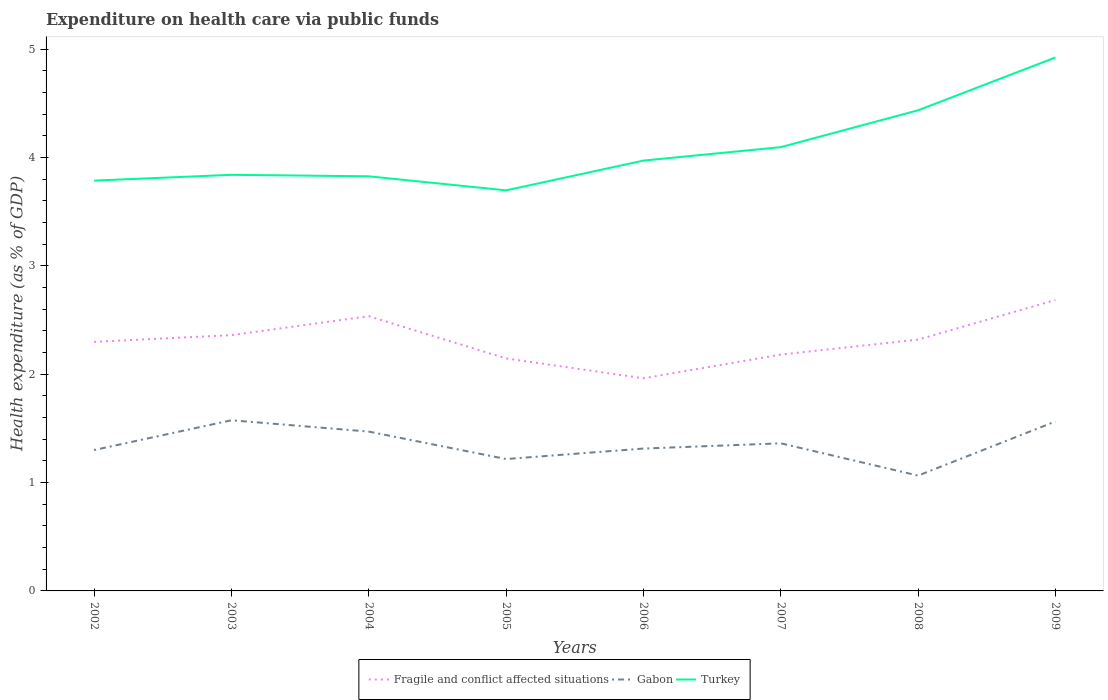How many different coloured lines are there?
Keep it short and to the point. 3. Does the line corresponding to Fragile and conflict affected situations intersect with the line corresponding to Turkey?
Ensure brevity in your answer.  No. Is the number of lines equal to the number of legend labels?
Ensure brevity in your answer.  Yes. Across all years, what is the maximum expenditure made on health care in Gabon?
Provide a succinct answer. 1.06. What is the total expenditure made on health care in Turkey in the graph?
Ensure brevity in your answer.  0.14. What is the difference between the highest and the second highest expenditure made on health care in Turkey?
Offer a terse response. 1.23. What is the difference between the highest and the lowest expenditure made on health care in Gabon?
Make the answer very short. 4. Is the expenditure made on health care in Turkey strictly greater than the expenditure made on health care in Fragile and conflict affected situations over the years?
Offer a terse response. No. What is the difference between two consecutive major ticks on the Y-axis?
Your answer should be very brief. 1. Does the graph contain grids?
Offer a terse response. No. How many legend labels are there?
Provide a short and direct response. 3. How are the legend labels stacked?
Give a very brief answer. Horizontal. What is the title of the graph?
Give a very brief answer. Expenditure on health care via public funds. Does "Aruba" appear as one of the legend labels in the graph?
Provide a short and direct response. No. What is the label or title of the Y-axis?
Your response must be concise. Health expenditure (as % of GDP). What is the Health expenditure (as % of GDP) in Fragile and conflict affected situations in 2002?
Offer a terse response. 2.3. What is the Health expenditure (as % of GDP) in Gabon in 2002?
Offer a terse response. 1.3. What is the Health expenditure (as % of GDP) in Turkey in 2002?
Your response must be concise. 3.79. What is the Health expenditure (as % of GDP) of Fragile and conflict affected situations in 2003?
Offer a very short reply. 2.36. What is the Health expenditure (as % of GDP) in Gabon in 2003?
Your answer should be very brief. 1.57. What is the Health expenditure (as % of GDP) of Turkey in 2003?
Keep it short and to the point. 3.84. What is the Health expenditure (as % of GDP) in Fragile and conflict affected situations in 2004?
Provide a short and direct response. 2.54. What is the Health expenditure (as % of GDP) in Gabon in 2004?
Give a very brief answer. 1.47. What is the Health expenditure (as % of GDP) of Turkey in 2004?
Offer a terse response. 3.83. What is the Health expenditure (as % of GDP) of Fragile and conflict affected situations in 2005?
Your answer should be very brief. 2.15. What is the Health expenditure (as % of GDP) of Gabon in 2005?
Provide a succinct answer. 1.22. What is the Health expenditure (as % of GDP) of Turkey in 2005?
Your response must be concise. 3.7. What is the Health expenditure (as % of GDP) in Fragile and conflict affected situations in 2006?
Your answer should be very brief. 1.96. What is the Health expenditure (as % of GDP) of Gabon in 2006?
Offer a terse response. 1.31. What is the Health expenditure (as % of GDP) of Turkey in 2006?
Provide a succinct answer. 3.97. What is the Health expenditure (as % of GDP) of Fragile and conflict affected situations in 2007?
Ensure brevity in your answer.  2.18. What is the Health expenditure (as % of GDP) in Gabon in 2007?
Keep it short and to the point. 1.36. What is the Health expenditure (as % of GDP) of Turkey in 2007?
Make the answer very short. 4.1. What is the Health expenditure (as % of GDP) of Fragile and conflict affected situations in 2008?
Your answer should be very brief. 2.32. What is the Health expenditure (as % of GDP) in Gabon in 2008?
Ensure brevity in your answer.  1.06. What is the Health expenditure (as % of GDP) of Turkey in 2008?
Offer a terse response. 4.44. What is the Health expenditure (as % of GDP) of Fragile and conflict affected situations in 2009?
Your answer should be compact. 2.68. What is the Health expenditure (as % of GDP) of Gabon in 2009?
Give a very brief answer. 1.56. What is the Health expenditure (as % of GDP) in Turkey in 2009?
Ensure brevity in your answer.  4.92. Across all years, what is the maximum Health expenditure (as % of GDP) in Fragile and conflict affected situations?
Offer a terse response. 2.68. Across all years, what is the maximum Health expenditure (as % of GDP) of Gabon?
Keep it short and to the point. 1.57. Across all years, what is the maximum Health expenditure (as % of GDP) in Turkey?
Your response must be concise. 4.92. Across all years, what is the minimum Health expenditure (as % of GDP) in Fragile and conflict affected situations?
Make the answer very short. 1.96. Across all years, what is the minimum Health expenditure (as % of GDP) of Gabon?
Make the answer very short. 1.06. Across all years, what is the minimum Health expenditure (as % of GDP) of Turkey?
Your response must be concise. 3.7. What is the total Health expenditure (as % of GDP) of Fragile and conflict affected situations in the graph?
Your response must be concise. 18.49. What is the total Health expenditure (as % of GDP) of Gabon in the graph?
Your answer should be very brief. 10.87. What is the total Health expenditure (as % of GDP) in Turkey in the graph?
Keep it short and to the point. 32.57. What is the difference between the Health expenditure (as % of GDP) of Fragile and conflict affected situations in 2002 and that in 2003?
Your response must be concise. -0.06. What is the difference between the Health expenditure (as % of GDP) in Gabon in 2002 and that in 2003?
Offer a terse response. -0.27. What is the difference between the Health expenditure (as % of GDP) of Turkey in 2002 and that in 2003?
Ensure brevity in your answer.  -0.05. What is the difference between the Health expenditure (as % of GDP) of Fragile and conflict affected situations in 2002 and that in 2004?
Your answer should be compact. -0.24. What is the difference between the Health expenditure (as % of GDP) of Gabon in 2002 and that in 2004?
Your answer should be compact. -0.17. What is the difference between the Health expenditure (as % of GDP) of Turkey in 2002 and that in 2004?
Keep it short and to the point. -0.04. What is the difference between the Health expenditure (as % of GDP) of Fragile and conflict affected situations in 2002 and that in 2005?
Offer a very short reply. 0.15. What is the difference between the Health expenditure (as % of GDP) of Gabon in 2002 and that in 2005?
Keep it short and to the point. 0.08. What is the difference between the Health expenditure (as % of GDP) in Turkey in 2002 and that in 2005?
Keep it short and to the point. 0.09. What is the difference between the Health expenditure (as % of GDP) in Fragile and conflict affected situations in 2002 and that in 2006?
Give a very brief answer. 0.34. What is the difference between the Health expenditure (as % of GDP) of Gabon in 2002 and that in 2006?
Provide a succinct answer. -0.01. What is the difference between the Health expenditure (as % of GDP) in Turkey in 2002 and that in 2006?
Keep it short and to the point. -0.18. What is the difference between the Health expenditure (as % of GDP) of Fragile and conflict affected situations in 2002 and that in 2007?
Offer a very short reply. 0.12. What is the difference between the Health expenditure (as % of GDP) in Gabon in 2002 and that in 2007?
Provide a succinct answer. -0.06. What is the difference between the Health expenditure (as % of GDP) of Turkey in 2002 and that in 2007?
Your answer should be very brief. -0.31. What is the difference between the Health expenditure (as % of GDP) in Fragile and conflict affected situations in 2002 and that in 2008?
Your response must be concise. -0.02. What is the difference between the Health expenditure (as % of GDP) of Gabon in 2002 and that in 2008?
Give a very brief answer. 0.24. What is the difference between the Health expenditure (as % of GDP) of Turkey in 2002 and that in 2008?
Ensure brevity in your answer.  -0.65. What is the difference between the Health expenditure (as % of GDP) in Fragile and conflict affected situations in 2002 and that in 2009?
Your answer should be very brief. -0.39. What is the difference between the Health expenditure (as % of GDP) in Gabon in 2002 and that in 2009?
Your answer should be compact. -0.26. What is the difference between the Health expenditure (as % of GDP) of Turkey in 2002 and that in 2009?
Keep it short and to the point. -1.14. What is the difference between the Health expenditure (as % of GDP) of Fragile and conflict affected situations in 2003 and that in 2004?
Your answer should be compact. -0.17. What is the difference between the Health expenditure (as % of GDP) in Gabon in 2003 and that in 2004?
Ensure brevity in your answer.  0.1. What is the difference between the Health expenditure (as % of GDP) in Turkey in 2003 and that in 2004?
Offer a terse response. 0.01. What is the difference between the Health expenditure (as % of GDP) in Fragile and conflict affected situations in 2003 and that in 2005?
Keep it short and to the point. 0.21. What is the difference between the Health expenditure (as % of GDP) in Gabon in 2003 and that in 2005?
Provide a short and direct response. 0.36. What is the difference between the Health expenditure (as % of GDP) in Turkey in 2003 and that in 2005?
Provide a short and direct response. 0.14. What is the difference between the Health expenditure (as % of GDP) of Fragile and conflict affected situations in 2003 and that in 2006?
Offer a very short reply. 0.4. What is the difference between the Health expenditure (as % of GDP) of Gabon in 2003 and that in 2006?
Your response must be concise. 0.26. What is the difference between the Health expenditure (as % of GDP) in Turkey in 2003 and that in 2006?
Give a very brief answer. -0.13. What is the difference between the Health expenditure (as % of GDP) in Fragile and conflict affected situations in 2003 and that in 2007?
Offer a terse response. 0.18. What is the difference between the Health expenditure (as % of GDP) of Gabon in 2003 and that in 2007?
Your answer should be very brief. 0.21. What is the difference between the Health expenditure (as % of GDP) in Turkey in 2003 and that in 2007?
Your answer should be very brief. -0.26. What is the difference between the Health expenditure (as % of GDP) in Fragile and conflict affected situations in 2003 and that in 2008?
Ensure brevity in your answer.  0.04. What is the difference between the Health expenditure (as % of GDP) of Gabon in 2003 and that in 2008?
Your answer should be very brief. 0.51. What is the difference between the Health expenditure (as % of GDP) in Turkey in 2003 and that in 2008?
Provide a succinct answer. -0.6. What is the difference between the Health expenditure (as % of GDP) in Fragile and conflict affected situations in 2003 and that in 2009?
Keep it short and to the point. -0.32. What is the difference between the Health expenditure (as % of GDP) in Gabon in 2003 and that in 2009?
Ensure brevity in your answer.  0.01. What is the difference between the Health expenditure (as % of GDP) of Turkey in 2003 and that in 2009?
Your answer should be very brief. -1.08. What is the difference between the Health expenditure (as % of GDP) of Fragile and conflict affected situations in 2004 and that in 2005?
Your answer should be compact. 0.39. What is the difference between the Health expenditure (as % of GDP) in Gabon in 2004 and that in 2005?
Give a very brief answer. 0.25. What is the difference between the Health expenditure (as % of GDP) in Turkey in 2004 and that in 2005?
Ensure brevity in your answer.  0.13. What is the difference between the Health expenditure (as % of GDP) in Fragile and conflict affected situations in 2004 and that in 2006?
Give a very brief answer. 0.57. What is the difference between the Health expenditure (as % of GDP) of Gabon in 2004 and that in 2006?
Your answer should be very brief. 0.16. What is the difference between the Health expenditure (as % of GDP) in Turkey in 2004 and that in 2006?
Give a very brief answer. -0.14. What is the difference between the Health expenditure (as % of GDP) in Fragile and conflict affected situations in 2004 and that in 2007?
Your answer should be compact. 0.35. What is the difference between the Health expenditure (as % of GDP) in Gabon in 2004 and that in 2007?
Ensure brevity in your answer.  0.11. What is the difference between the Health expenditure (as % of GDP) in Turkey in 2004 and that in 2007?
Offer a terse response. -0.27. What is the difference between the Health expenditure (as % of GDP) in Fragile and conflict affected situations in 2004 and that in 2008?
Make the answer very short. 0.22. What is the difference between the Health expenditure (as % of GDP) of Gabon in 2004 and that in 2008?
Give a very brief answer. 0.41. What is the difference between the Health expenditure (as % of GDP) in Turkey in 2004 and that in 2008?
Provide a short and direct response. -0.61. What is the difference between the Health expenditure (as % of GDP) of Fragile and conflict affected situations in 2004 and that in 2009?
Your answer should be very brief. -0.15. What is the difference between the Health expenditure (as % of GDP) of Gabon in 2004 and that in 2009?
Your answer should be very brief. -0.09. What is the difference between the Health expenditure (as % of GDP) of Turkey in 2004 and that in 2009?
Offer a terse response. -1.1. What is the difference between the Health expenditure (as % of GDP) of Fragile and conflict affected situations in 2005 and that in 2006?
Your answer should be very brief. 0.18. What is the difference between the Health expenditure (as % of GDP) in Gabon in 2005 and that in 2006?
Give a very brief answer. -0.1. What is the difference between the Health expenditure (as % of GDP) in Turkey in 2005 and that in 2006?
Offer a terse response. -0.27. What is the difference between the Health expenditure (as % of GDP) of Fragile and conflict affected situations in 2005 and that in 2007?
Provide a short and direct response. -0.04. What is the difference between the Health expenditure (as % of GDP) of Gabon in 2005 and that in 2007?
Give a very brief answer. -0.14. What is the difference between the Health expenditure (as % of GDP) in Turkey in 2005 and that in 2007?
Keep it short and to the point. -0.4. What is the difference between the Health expenditure (as % of GDP) of Fragile and conflict affected situations in 2005 and that in 2008?
Offer a terse response. -0.17. What is the difference between the Health expenditure (as % of GDP) of Gabon in 2005 and that in 2008?
Make the answer very short. 0.15. What is the difference between the Health expenditure (as % of GDP) of Turkey in 2005 and that in 2008?
Your answer should be very brief. -0.74. What is the difference between the Health expenditure (as % of GDP) of Fragile and conflict affected situations in 2005 and that in 2009?
Make the answer very short. -0.54. What is the difference between the Health expenditure (as % of GDP) in Gabon in 2005 and that in 2009?
Offer a very short reply. -0.35. What is the difference between the Health expenditure (as % of GDP) of Turkey in 2005 and that in 2009?
Provide a short and direct response. -1.23. What is the difference between the Health expenditure (as % of GDP) of Fragile and conflict affected situations in 2006 and that in 2007?
Give a very brief answer. -0.22. What is the difference between the Health expenditure (as % of GDP) in Gabon in 2006 and that in 2007?
Ensure brevity in your answer.  -0.05. What is the difference between the Health expenditure (as % of GDP) of Turkey in 2006 and that in 2007?
Make the answer very short. -0.12. What is the difference between the Health expenditure (as % of GDP) in Fragile and conflict affected situations in 2006 and that in 2008?
Ensure brevity in your answer.  -0.36. What is the difference between the Health expenditure (as % of GDP) in Gabon in 2006 and that in 2008?
Offer a very short reply. 0.25. What is the difference between the Health expenditure (as % of GDP) of Turkey in 2006 and that in 2008?
Offer a terse response. -0.46. What is the difference between the Health expenditure (as % of GDP) in Fragile and conflict affected situations in 2006 and that in 2009?
Your answer should be compact. -0.72. What is the difference between the Health expenditure (as % of GDP) of Gabon in 2006 and that in 2009?
Ensure brevity in your answer.  -0.25. What is the difference between the Health expenditure (as % of GDP) in Turkey in 2006 and that in 2009?
Ensure brevity in your answer.  -0.95. What is the difference between the Health expenditure (as % of GDP) of Fragile and conflict affected situations in 2007 and that in 2008?
Your answer should be compact. -0.14. What is the difference between the Health expenditure (as % of GDP) of Gabon in 2007 and that in 2008?
Your answer should be compact. 0.3. What is the difference between the Health expenditure (as % of GDP) in Turkey in 2007 and that in 2008?
Offer a terse response. -0.34. What is the difference between the Health expenditure (as % of GDP) in Fragile and conflict affected situations in 2007 and that in 2009?
Ensure brevity in your answer.  -0.5. What is the difference between the Health expenditure (as % of GDP) of Gabon in 2007 and that in 2009?
Offer a very short reply. -0.2. What is the difference between the Health expenditure (as % of GDP) in Turkey in 2007 and that in 2009?
Ensure brevity in your answer.  -0.83. What is the difference between the Health expenditure (as % of GDP) in Fragile and conflict affected situations in 2008 and that in 2009?
Your answer should be very brief. -0.37. What is the difference between the Health expenditure (as % of GDP) in Gabon in 2008 and that in 2009?
Provide a short and direct response. -0.5. What is the difference between the Health expenditure (as % of GDP) in Turkey in 2008 and that in 2009?
Provide a short and direct response. -0.49. What is the difference between the Health expenditure (as % of GDP) in Fragile and conflict affected situations in 2002 and the Health expenditure (as % of GDP) in Gabon in 2003?
Provide a short and direct response. 0.72. What is the difference between the Health expenditure (as % of GDP) in Fragile and conflict affected situations in 2002 and the Health expenditure (as % of GDP) in Turkey in 2003?
Ensure brevity in your answer.  -1.54. What is the difference between the Health expenditure (as % of GDP) of Gabon in 2002 and the Health expenditure (as % of GDP) of Turkey in 2003?
Keep it short and to the point. -2.54. What is the difference between the Health expenditure (as % of GDP) in Fragile and conflict affected situations in 2002 and the Health expenditure (as % of GDP) in Gabon in 2004?
Provide a short and direct response. 0.83. What is the difference between the Health expenditure (as % of GDP) of Fragile and conflict affected situations in 2002 and the Health expenditure (as % of GDP) of Turkey in 2004?
Keep it short and to the point. -1.53. What is the difference between the Health expenditure (as % of GDP) of Gabon in 2002 and the Health expenditure (as % of GDP) of Turkey in 2004?
Ensure brevity in your answer.  -2.53. What is the difference between the Health expenditure (as % of GDP) in Fragile and conflict affected situations in 2002 and the Health expenditure (as % of GDP) in Gabon in 2005?
Your answer should be very brief. 1.08. What is the difference between the Health expenditure (as % of GDP) in Fragile and conflict affected situations in 2002 and the Health expenditure (as % of GDP) in Turkey in 2005?
Your answer should be compact. -1.4. What is the difference between the Health expenditure (as % of GDP) of Gabon in 2002 and the Health expenditure (as % of GDP) of Turkey in 2005?
Provide a succinct answer. -2.4. What is the difference between the Health expenditure (as % of GDP) in Fragile and conflict affected situations in 2002 and the Health expenditure (as % of GDP) in Gabon in 2006?
Give a very brief answer. 0.98. What is the difference between the Health expenditure (as % of GDP) in Fragile and conflict affected situations in 2002 and the Health expenditure (as % of GDP) in Turkey in 2006?
Your response must be concise. -1.67. What is the difference between the Health expenditure (as % of GDP) in Gabon in 2002 and the Health expenditure (as % of GDP) in Turkey in 2006?
Offer a terse response. -2.67. What is the difference between the Health expenditure (as % of GDP) in Fragile and conflict affected situations in 2002 and the Health expenditure (as % of GDP) in Gabon in 2007?
Offer a very short reply. 0.94. What is the difference between the Health expenditure (as % of GDP) in Fragile and conflict affected situations in 2002 and the Health expenditure (as % of GDP) in Turkey in 2007?
Your answer should be compact. -1.8. What is the difference between the Health expenditure (as % of GDP) in Gabon in 2002 and the Health expenditure (as % of GDP) in Turkey in 2007?
Your response must be concise. -2.8. What is the difference between the Health expenditure (as % of GDP) of Fragile and conflict affected situations in 2002 and the Health expenditure (as % of GDP) of Gabon in 2008?
Your response must be concise. 1.23. What is the difference between the Health expenditure (as % of GDP) of Fragile and conflict affected situations in 2002 and the Health expenditure (as % of GDP) of Turkey in 2008?
Offer a terse response. -2.14. What is the difference between the Health expenditure (as % of GDP) in Gabon in 2002 and the Health expenditure (as % of GDP) in Turkey in 2008?
Your answer should be compact. -3.14. What is the difference between the Health expenditure (as % of GDP) of Fragile and conflict affected situations in 2002 and the Health expenditure (as % of GDP) of Gabon in 2009?
Offer a very short reply. 0.73. What is the difference between the Health expenditure (as % of GDP) in Fragile and conflict affected situations in 2002 and the Health expenditure (as % of GDP) in Turkey in 2009?
Offer a very short reply. -2.62. What is the difference between the Health expenditure (as % of GDP) in Gabon in 2002 and the Health expenditure (as % of GDP) in Turkey in 2009?
Provide a short and direct response. -3.62. What is the difference between the Health expenditure (as % of GDP) of Fragile and conflict affected situations in 2003 and the Health expenditure (as % of GDP) of Gabon in 2004?
Keep it short and to the point. 0.89. What is the difference between the Health expenditure (as % of GDP) in Fragile and conflict affected situations in 2003 and the Health expenditure (as % of GDP) in Turkey in 2004?
Provide a short and direct response. -1.47. What is the difference between the Health expenditure (as % of GDP) of Gabon in 2003 and the Health expenditure (as % of GDP) of Turkey in 2004?
Provide a short and direct response. -2.25. What is the difference between the Health expenditure (as % of GDP) in Fragile and conflict affected situations in 2003 and the Health expenditure (as % of GDP) in Gabon in 2005?
Offer a very short reply. 1.14. What is the difference between the Health expenditure (as % of GDP) in Fragile and conflict affected situations in 2003 and the Health expenditure (as % of GDP) in Turkey in 2005?
Give a very brief answer. -1.34. What is the difference between the Health expenditure (as % of GDP) in Gabon in 2003 and the Health expenditure (as % of GDP) in Turkey in 2005?
Your response must be concise. -2.12. What is the difference between the Health expenditure (as % of GDP) of Fragile and conflict affected situations in 2003 and the Health expenditure (as % of GDP) of Gabon in 2006?
Your answer should be very brief. 1.05. What is the difference between the Health expenditure (as % of GDP) of Fragile and conflict affected situations in 2003 and the Health expenditure (as % of GDP) of Turkey in 2006?
Your response must be concise. -1.61. What is the difference between the Health expenditure (as % of GDP) of Gabon in 2003 and the Health expenditure (as % of GDP) of Turkey in 2006?
Your answer should be very brief. -2.4. What is the difference between the Health expenditure (as % of GDP) in Fragile and conflict affected situations in 2003 and the Health expenditure (as % of GDP) in Turkey in 2007?
Provide a short and direct response. -1.73. What is the difference between the Health expenditure (as % of GDP) in Gabon in 2003 and the Health expenditure (as % of GDP) in Turkey in 2007?
Offer a very short reply. -2.52. What is the difference between the Health expenditure (as % of GDP) in Fragile and conflict affected situations in 2003 and the Health expenditure (as % of GDP) in Gabon in 2008?
Your answer should be compact. 1.3. What is the difference between the Health expenditure (as % of GDP) of Fragile and conflict affected situations in 2003 and the Health expenditure (as % of GDP) of Turkey in 2008?
Your response must be concise. -2.07. What is the difference between the Health expenditure (as % of GDP) in Gabon in 2003 and the Health expenditure (as % of GDP) in Turkey in 2008?
Give a very brief answer. -2.86. What is the difference between the Health expenditure (as % of GDP) of Fragile and conflict affected situations in 2003 and the Health expenditure (as % of GDP) of Gabon in 2009?
Your answer should be very brief. 0.8. What is the difference between the Health expenditure (as % of GDP) of Fragile and conflict affected situations in 2003 and the Health expenditure (as % of GDP) of Turkey in 2009?
Provide a short and direct response. -2.56. What is the difference between the Health expenditure (as % of GDP) in Gabon in 2003 and the Health expenditure (as % of GDP) in Turkey in 2009?
Make the answer very short. -3.35. What is the difference between the Health expenditure (as % of GDP) in Fragile and conflict affected situations in 2004 and the Health expenditure (as % of GDP) in Gabon in 2005?
Ensure brevity in your answer.  1.32. What is the difference between the Health expenditure (as % of GDP) in Fragile and conflict affected situations in 2004 and the Health expenditure (as % of GDP) in Turkey in 2005?
Ensure brevity in your answer.  -1.16. What is the difference between the Health expenditure (as % of GDP) of Gabon in 2004 and the Health expenditure (as % of GDP) of Turkey in 2005?
Your answer should be compact. -2.23. What is the difference between the Health expenditure (as % of GDP) in Fragile and conflict affected situations in 2004 and the Health expenditure (as % of GDP) in Gabon in 2006?
Offer a terse response. 1.22. What is the difference between the Health expenditure (as % of GDP) in Fragile and conflict affected situations in 2004 and the Health expenditure (as % of GDP) in Turkey in 2006?
Ensure brevity in your answer.  -1.44. What is the difference between the Health expenditure (as % of GDP) in Gabon in 2004 and the Health expenditure (as % of GDP) in Turkey in 2006?
Your answer should be compact. -2.5. What is the difference between the Health expenditure (as % of GDP) in Fragile and conflict affected situations in 2004 and the Health expenditure (as % of GDP) in Gabon in 2007?
Offer a very short reply. 1.17. What is the difference between the Health expenditure (as % of GDP) of Fragile and conflict affected situations in 2004 and the Health expenditure (as % of GDP) of Turkey in 2007?
Your answer should be very brief. -1.56. What is the difference between the Health expenditure (as % of GDP) in Gabon in 2004 and the Health expenditure (as % of GDP) in Turkey in 2007?
Provide a succinct answer. -2.62. What is the difference between the Health expenditure (as % of GDP) of Fragile and conflict affected situations in 2004 and the Health expenditure (as % of GDP) of Gabon in 2008?
Give a very brief answer. 1.47. What is the difference between the Health expenditure (as % of GDP) of Gabon in 2004 and the Health expenditure (as % of GDP) of Turkey in 2008?
Provide a succinct answer. -2.97. What is the difference between the Health expenditure (as % of GDP) in Fragile and conflict affected situations in 2004 and the Health expenditure (as % of GDP) in Gabon in 2009?
Offer a very short reply. 0.97. What is the difference between the Health expenditure (as % of GDP) of Fragile and conflict affected situations in 2004 and the Health expenditure (as % of GDP) of Turkey in 2009?
Your response must be concise. -2.39. What is the difference between the Health expenditure (as % of GDP) in Gabon in 2004 and the Health expenditure (as % of GDP) in Turkey in 2009?
Keep it short and to the point. -3.45. What is the difference between the Health expenditure (as % of GDP) of Fragile and conflict affected situations in 2005 and the Health expenditure (as % of GDP) of Gabon in 2006?
Your response must be concise. 0.83. What is the difference between the Health expenditure (as % of GDP) in Fragile and conflict affected situations in 2005 and the Health expenditure (as % of GDP) in Turkey in 2006?
Give a very brief answer. -1.83. What is the difference between the Health expenditure (as % of GDP) in Gabon in 2005 and the Health expenditure (as % of GDP) in Turkey in 2006?
Ensure brevity in your answer.  -2.75. What is the difference between the Health expenditure (as % of GDP) of Fragile and conflict affected situations in 2005 and the Health expenditure (as % of GDP) of Gabon in 2007?
Provide a short and direct response. 0.78. What is the difference between the Health expenditure (as % of GDP) in Fragile and conflict affected situations in 2005 and the Health expenditure (as % of GDP) in Turkey in 2007?
Provide a succinct answer. -1.95. What is the difference between the Health expenditure (as % of GDP) of Gabon in 2005 and the Health expenditure (as % of GDP) of Turkey in 2007?
Offer a terse response. -2.88. What is the difference between the Health expenditure (as % of GDP) of Fragile and conflict affected situations in 2005 and the Health expenditure (as % of GDP) of Gabon in 2008?
Your answer should be very brief. 1.08. What is the difference between the Health expenditure (as % of GDP) of Fragile and conflict affected situations in 2005 and the Health expenditure (as % of GDP) of Turkey in 2008?
Provide a succinct answer. -2.29. What is the difference between the Health expenditure (as % of GDP) in Gabon in 2005 and the Health expenditure (as % of GDP) in Turkey in 2008?
Give a very brief answer. -3.22. What is the difference between the Health expenditure (as % of GDP) in Fragile and conflict affected situations in 2005 and the Health expenditure (as % of GDP) in Gabon in 2009?
Your answer should be very brief. 0.58. What is the difference between the Health expenditure (as % of GDP) in Fragile and conflict affected situations in 2005 and the Health expenditure (as % of GDP) in Turkey in 2009?
Provide a short and direct response. -2.78. What is the difference between the Health expenditure (as % of GDP) of Gabon in 2005 and the Health expenditure (as % of GDP) of Turkey in 2009?
Provide a succinct answer. -3.71. What is the difference between the Health expenditure (as % of GDP) of Fragile and conflict affected situations in 2006 and the Health expenditure (as % of GDP) of Gabon in 2007?
Make the answer very short. 0.6. What is the difference between the Health expenditure (as % of GDP) of Fragile and conflict affected situations in 2006 and the Health expenditure (as % of GDP) of Turkey in 2007?
Make the answer very short. -2.13. What is the difference between the Health expenditure (as % of GDP) of Gabon in 2006 and the Health expenditure (as % of GDP) of Turkey in 2007?
Keep it short and to the point. -2.78. What is the difference between the Health expenditure (as % of GDP) of Fragile and conflict affected situations in 2006 and the Health expenditure (as % of GDP) of Gabon in 2008?
Ensure brevity in your answer.  0.9. What is the difference between the Health expenditure (as % of GDP) of Fragile and conflict affected situations in 2006 and the Health expenditure (as % of GDP) of Turkey in 2008?
Offer a terse response. -2.47. What is the difference between the Health expenditure (as % of GDP) in Gabon in 2006 and the Health expenditure (as % of GDP) in Turkey in 2008?
Your answer should be compact. -3.12. What is the difference between the Health expenditure (as % of GDP) in Fragile and conflict affected situations in 2006 and the Health expenditure (as % of GDP) in Gabon in 2009?
Keep it short and to the point. 0.4. What is the difference between the Health expenditure (as % of GDP) of Fragile and conflict affected situations in 2006 and the Health expenditure (as % of GDP) of Turkey in 2009?
Give a very brief answer. -2.96. What is the difference between the Health expenditure (as % of GDP) in Gabon in 2006 and the Health expenditure (as % of GDP) in Turkey in 2009?
Keep it short and to the point. -3.61. What is the difference between the Health expenditure (as % of GDP) of Fragile and conflict affected situations in 2007 and the Health expenditure (as % of GDP) of Gabon in 2008?
Your answer should be compact. 1.12. What is the difference between the Health expenditure (as % of GDP) of Fragile and conflict affected situations in 2007 and the Health expenditure (as % of GDP) of Turkey in 2008?
Provide a succinct answer. -2.25. What is the difference between the Health expenditure (as % of GDP) in Gabon in 2007 and the Health expenditure (as % of GDP) in Turkey in 2008?
Give a very brief answer. -3.07. What is the difference between the Health expenditure (as % of GDP) in Fragile and conflict affected situations in 2007 and the Health expenditure (as % of GDP) in Gabon in 2009?
Ensure brevity in your answer.  0.62. What is the difference between the Health expenditure (as % of GDP) of Fragile and conflict affected situations in 2007 and the Health expenditure (as % of GDP) of Turkey in 2009?
Your response must be concise. -2.74. What is the difference between the Health expenditure (as % of GDP) in Gabon in 2007 and the Health expenditure (as % of GDP) in Turkey in 2009?
Your response must be concise. -3.56. What is the difference between the Health expenditure (as % of GDP) in Fragile and conflict affected situations in 2008 and the Health expenditure (as % of GDP) in Gabon in 2009?
Offer a terse response. 0.76. What is the difference between the Health expenditure (as % of GDP) in Fragile and conflict affected situations in 2008 and the Health expenditure (as % of GDP) in Turkey in 2009?
Your answer should be very brief. -2.6. What is the difference between the Health expenditure (as % of GDP) in Gabon in 2008 and the Health expenditure (as % of GDP) in Turkey in 2009?
Your response must be concise. -3.86. What is the average Health expenditure (as % of GDP) in Fragile and conflict affected situations per year?
Make the answer very short. 2.31. What is the average Health expenditure (as % of GDP) in Gabon per year?
Your answer should be very brief. 1.36. What is the average Health expenditure (as % of GDP) in Turkey per year?
Make the answer very short. 4.07. In the year 2002, what is the difference between the Health expenditure (as % of GDP) in Fragile and conflict affected situations and Health expenditure (as % of GDP) in Gabon?
Ensure brevity in your answer.  1. In the year 2002, what is the difference between the Health expenditure (as % of GDP) of Fragile and conflict affected situations and Health expenditure (as % of GDP) of Turkey?
Make the answer very short. -1.49. In the year 2002, what is the difference between the Health expenditure (as % of GDP) of Gabon and Health expenditure (as % of GDP) of Turkey?
Make the answer very short. -2.49. In the year 2003, what is the difference between the Health expenditure (as % of GDP) in Fragile and conflict affected situations and Health expenditure (as % of GDP) in Gabon?
Ensure brevity in your answer.  0.79. In the year 2003, what is the difference between the Health expenditure (as % of GDP) of Fragile and conflict affected situations and Health expenditure (as % of GDP) of Turkey?
Ensure brevity in your answer.  -1.48. In the year 2003, what is the difference between the Health expenditure (as % of GDP) in Gabon and Health expenditure (as % of GDP) in Turkey?
Offer a very short reply. -2.26. In the year 2004, what is the difference between the Health expenditure (as % of GDP) of Fragile and conflict affected situations and Health expenditure (as % of GDP) of Gabon?
Your answer should be compact. 1.07. In the year 2004, what is the difference between the Health expenditure (as % of GDP) in Fragile and conflict affected situations and Health expenditure (as % of GDP) in Turkey?
Offer a very short reply. -1.29. In the year 2004, what is the difference between the Health expenditure (as % of GDP) in Gabon and Health expenditure (as % of GDP) in Turkey?
Give a very brief answer. -2.36. In the year 2005, what is the difference between the Health expenditure (as % of GDP) of Fragile and conflict affected situations and Health expenditure (as % of GDP) of Gabon?
Your answer should be compact. 0.93. In the year 2005, what is the difference between the Health expenditure (as % of GDP) in Fragile and conflict affected situations and Health expenditure (as % of GDP) in Turkey?
Your answer should be very brief. -1.55. In the year 2005, what is the difference between the Health expenditure (as % of GDP) in Gabon and Health expenditure (as % of GDP) in Turkey?
Offer a terse response. -2.48. In the year 2006, what is the difference between the Health expenditure (as % of GDP) in Fragile and conflict affected situations and Health expenditure (as % of GDP) in Gabon?
Your response must be concise. 0.65. In the year 2006, what is the difference between the Health expenditure (as % of GDP) of Fragile and conflict affected situations and Health expenditure (as % of GDP) of Turkey?
Provide a short and direct response. -2.01. In the year 2006, what is the difference between the Health expenditure (as % of GDP) in Gabon and Health expenditure (as % of GDP) in Turkey?
Your answer should be very brief. -2.66. In the year 2007, what is the difference between the Health expenditure (as % of GDP) of Fragile and conflict affected situations and Health expenditure (as % of GDP) of Gabon?
Ensure brevity in your answer.  0.82. In the year 2007, what is the difference between the Health expenditure (as % of GDP) in Fragile and conflict affected situations and Health expenditure (as % of GDP) in Turkey?
Your answer should be very brief. -1.91. In the year 2007, what is the difference between the Health expenditure (as % of GDP) in Gabon and Health expenditure (as % of GDP) in Turkey?
Keep it short and to the point. -2.73. In the year 2008, what is the difference between the Health expenditure (as % of GDP) in Fragile and conflict affected situations and Health expenditure (as % of GDP) in Gabon?
Your response must be concise. 1.26. In the year 2008, what is the difference between the Health expenditure (as % of GDP) in Fragile and conflict affected situations and Health expenditure (as % of GDP) in Turkey?
Make the answer very short. -2.12. In the year 2008, what is the difference between the Health expenditure (as % of GDP) in Gabon and Health expenditure (as % of GDP) in Turkey?
Ensure brevity in your answer.  -3.37. In the year 2009, what is the difference between the Health expenditure (as % of GDP) in Fragile and conflict affected situations and Health expenditure (as % of GDP) in Gabon?
Your answer should be very brief. 1.12. In the year 2009, what is the difference between the Health expenditure (as % of GDP) in Fragile and conflict affected situations and Health expenditure (as % of GDP) in Turkey?
Your answer should be very brief. -2.24. In the year 2009, what is the difference between the Health expenditure (as % of GDP) of Gabon and Health expenditure (as % of GDP) of Turkey?
Make the answer very short. -3.36. What is the ratio of the Health expenditure (as % of GDP) of Fragile and conflict affected situations in 2002 to that in 2003?
Keep it short and to the point. 0.97. What is the ratio of the Health expenditure (as % of GDP) of Gabon in 2002 to that in 2003?
Give a very brief answer. 0.83. What is the ratio of the Health expenditure (as % of GDP) of Turkey in 2002 to that in 2003?
Give a very brief answer. 0.99. What is the ratio of the Health expenditure (as % of GDP) of Fragile and conflict affected situations in 2002 to that in 2004?
Provide a short and direct response. 0.91. What is the ratio of the Health expenditure (as % of GDP) in Gabon in 2002 to that in 2004?
Ensure brevity in your answer.  0.88. What is the ratio of the Health expenditure (as % of GDP) of Fragile and conflict affected situations in 2002 to that in 2005?
Your response must be concise. 1.07. What is the ratio of the Health expenditure (as % of GDP) in Gabon in 2002 to that in 2005?
Your response must be concise. 1.07. What is the ratio of the Health expenditure (as % of GDP) in Turkey in 2002 to that in 2005?
Your answer should be very brief. 1.02. What is the ratio of the Health expenditure (as % of GDP) in Fragile and conflict affected situations in 2002 to that in 2006?
Make the answer very short. 1.17. What is the ratio of the Health expenditure (as % of GDP) of Turkey in 2002 to that in 2006?
Your answer should be compact. 0.95. What is the ratio of the Health expenditure (as % of GDP) of Fragile and conflict affected situations in 2002 to that in 2007?
Provide a short and direct response. 1.05. What is the ratio of the Health expenditure (as % of GDP) of Gabon in 2002 to that in 2007?
Your answer should be compact. 0.95. What is the ratio of the Health expenditure (as % of GDP) of Turkey in 2002 to that in 2007?
Keep it short and to the point. 0.92. What is the ratio of the Health expenditure (as % of GDP) of Fragile and conflict affected situations in 2002 to that in 2008?
Ensure brevity in your answer.  0.99. What is the ratio of the Health expenditure (as % of GDP) in Gabon in 2002 to that in 2008?
Keep it short and to the point. 1.22. What is the ratio of the Health expenditure (as % of GDP) in Turkey in 2002 to that in 2008?
Make the answer very short. 0.85. What is the ratio of the Health expenditure (as % of GDP) in Fragile and conflict affected situations in 2002 to that in 2009?
Provide a short and direct response. 0.86. What is the ratio of the Health expenditure (as % of GDP) of Gabon in 2002 to that in 2009?
Give a very brief answer. 0.83. What is the ratio of the Health expenditure (as % of GDP) in Turkey in 2002 to that in 2009?
Make the answer very short. 0.77. What is the ratio of the Health expenditure (as % of GDP) in Fragile and conflict affected situations in 2003 to that in 2004?
Provide a succinct answer. 0.93. What is the ratio of the Health expenditure (as % of GDP) in Gabon in 2003 to that in 2004?
Your response must be concise. 1.07. What is the ratio of the Health expenditure (as % of GDP) of Fragile and conflict affected situations in 2003 to that in 2005?
Your answer should be compact. 1.1. What is the ratio of the Health expenditure (as % of GDP) of Gabon in 2003 to that in 2005?
Provide a short and direct response. 1.29. What is the ratio of the Health expenditure (as % of GDP) in Turkey in 2003 to that in 2005?
Provide a succinct answer. 1.04. What is the ratio of the Health expenditure (as % of GDP) of Fragile and conflict affected situations in 2003 to that in 2006?
Your answer should be very brief. 1.2. What is the ratio of the Health expenditure (as % of GDP) of Gabon in 2003 to that in 2006?
Your response must be concise. 1.2. What is the ratio of the Health expenditure (as % of GDP) of Turkey in 2003 to that in 2006?
Your answer should be very brief. 0.97. What is the ratio of the Health expenditure (as % of GDP) of Fragile and conflict affected situations in 2003 to that in 2007?
Keep it short and to the point. 1.08. What is the ratio of the Health expenditure (as % of GDP) in Gabon in 2003 to that in 2007?
Your answer should be very brief. 1.16. What is the ratio of the Health expenditure (as % of GDP) of Turkey in 2003 to that in 2007?
Keep it short and to the point. 0.94. What is the ratio of the Health expenditure (as % of GDP) of Fragile and conflict affected situations in 2003 to that in 2008?
Offer a terse response. 1.02. What is the ratio of the Health expenditure (as % of GDP) in Gabon in 2003 to that in 2008?
Make the answer very short. 1.48. What is the ratio of the Health expenditure (as % of GDP) of Turkey in 2003 to that in 2008?
Give a very brief answer. 0.87. What is the ratio of the Health expenditure (as % of GDP) of Fragile and conflict affected situations in 2003 to that in 2009?
Give a very brief answer. 0.88. What is the ratio of the Health expenditure (as % of GDP) of Gabon in 2003 to that in 2009?
Offer a terse response. 1.01. What is the ratio of the Health expenditure (as % of GDP) in Turkey in 2003 to that in 2009?
Your answer should be compact. 0.78. What is the ratio of the Health expenditure (as % of GDP) in Fragile and conflict affected situations in 2004 to that in 2005?
Give a very brief answer. 1.18. What is the ratio of the Health expenditure (as % of GDP) of Gabon in 2004 to that in 2005?
Provide a succinct answer. 1.21. What is the ratio of the Health expenditure (as % of GDP) of Turkey in 2004 to that in 2005?
Your answer should be compact. 1.04. What is the ratio of the Health expenditure (as % of GDP) in Fragile and conflict affected situations in 2004 to that in 2006?
Keep it short and to the point. 1.29. What is the ratio of the Health expenditure (as % of GDP) of Gabon in 2004 to that in 2006?
Offer a very short reply. 1.12. What is the ratio of the Health expenditure (as % of GDP) in Turkey in 2004 to that in 2006?
Provide a succinct answer. 0.96. What is the ratio of the Health expenditure (as % of GDP) in Fragile and conflict affected situations in 2004 to that in 2007?
Ensure brevity in your answer.  1.16. What is the ratio of the Health expenditure (as % of GDP) of Gabon in 2004 to that in 2007?
Your answer should be compact. 1.08. What is the ratio of the Health expenditure (as % of GDP) in Turkey in 2004 to that in 2007?
Offer a very short reply. 0.93. What is the ratio of the Health expenditure (as % of GDP) of Fragile and conflict affected situations in 2004 to that in 2008?
Your answer should be compact. 1.09. What is the ratio of the Health expenditure (as % of GDP) in Gabon in 2004 to that in 2008?
Provide a succinct answer. 1.38. What is the ratio of the Health expenditure (as % of GDP) of Turkey in 2004 to that in 2008?
Ensure brevity in your answer.  0.86. What is the ratio of the Health expenditure (as % of GDP) in Fragile and conflict affected situations in 2004 to that in 2009?
Keep it short and to the point. 0.94. What is the ratio of the Health expenditure (as % of GDP) of Gabon in 2004 to that in 2009?
Keep it short and to the point. 0.94. What is the ratio of the Health expenditure (as % of GDP) in Turkey in 2004 to that in 2009?
Provide a short and direct response. 0.78. What is the ratio of the Health expenditure (as % of GDP) of Fragile and conflict affected situations in 2005 to that in 2006?
Ensure brevity in your answer.  1.09. What is the ratio of the Health expenditure (as % of GDP) in Gabon in 2005 to that in 2006?
Keep it short and to the point. 0.93. What is the ratio of the Health expenditure (as % of GDP) in Turkey in 2005 to that in 2006?
Your response must be concise. 0.93. What is the ratio of the Health expenditure (as % of GDP) of Fragile and conflict affected situations in 2005 to that in 2007?
Provide a succinct answer. 0.98. What is the ratio of the Health expenditure (as % of GDP) in Gabon in 2005 to that in 2007?
Ensure brevity in your answer.  0.89. What is the ratio of the Health expenditure (as % of GDP) of Turkey in 2005 to that in 2007?
Your answer should be very brief. 0.9. What is the ratio of the Health expenditure (as % of GDP) in Fragile and conflict affected situations in 2005 to that in 2008?
Give a very brief answer. 0.93. What is the ratio of the Health expenditure (as % of GDP) in Gabon in 2005 to that in 2008?
Keep it short and to the point. 1.14. What is the ratio of the Health expenditure (as % of GDP) of Turkey in 2005 to that in 2008?
Your answer should be compact. 0.83. What is the ratio of the Health expenditure (as % of GDP) in Fragile and conflict affected situations in 2005 to that in 2009?
Provide a short and direct response. 0.8. What is the ratio of the Health expenditure (as % of GDP) of Gabon in 2005 to that in 2009?
Offer a very short reply. 0.78. What is the ratio of the Health expenditure (as % of GDP) in Turkey in 2005 to that in 2009?
Your answer should be compact. 0.75. What is the ratio of the Health expenditure (as % of GDP) in Fragile and conflict affected situations in 2006 to that in 2007?
Keep it short and to the point. 0.9. What is the ratio of the Health expenditure (as % of GDP) of Gabon in 2006 to that in 2007?
Your answer should be very brief. 0.96. What is the ratio of the Health expenditure (as % of GDP) of Turkey in 2006 to that in 2007?
Make the answer very short. 0.97. What is the ratio of the Health expenditure (as % of GDP) in Fragile and conflict affected situations in 2006 to that in 2008?
Your answer should be compact. 0.85. What is the ratio of the Health expenditure (as % of GDP) of Gabon in 2006 to that in 2008?
Give a very brief answer. 1.23. What is the ratio of the Health expenditure (as % of GDP) in Turkey in 2006 to that in 2008?
Your response must be concise. 0.9. What is the ratio of the Health expenditure (as % of GDP) of Fragile and conflict affected situations in 2006 to that in 2009?
Provide a short and direct response. 0.73. What is the ratio of the Health expenditure (as % of GDP) in Gabon in 2006 to that in 2009?
Give a very brief answer. 0.84. What is the ratio of the Health expenditure (as % of GDP) in Turkey in 2006 to that in 2009?
Make the answer very short. 0.81. What is the ratio of the Health expenditure (as % of GDP) in Fragile and conflict affected situations in 2007 to that in 2008?
Make the answer very short. 0.94. What is the ratio of the Health expenditure (as % of GDP) of Gabon in 2007 to that in 2008?
Offer a very short reply. 1.28. What is the ratio of the Health expenditure (as % of GDP) in Turkey in 2007 to that in 2008?
Offer a very short reply. 0.92. What is the ratio of the Health expenditure (as % of GDP) of Fragile and conflict affected situations in 2007 to that in 2009?
Offer a very short reply. 0.81. What is the ratio of the Health expenditure (as % of GDP) in Gabon in 2007 to that in 2009?
Offer a terse response. 0.87. What is the ratio of the Health expenditure (as % of GDP) of Turkey in 2007 to that in 2009?
Your answer should be compact. 0.83. What is the ratio of the Health expenditure (as % of GDP) of Fragile and conflict affected situations in 2008 to that in 2009?
Offer a terse response. 0.86. What is the ratio of the Health expenditure (as % of GDP) of Gabon in 2008 to that in 2009?
Your response must be concise. 0.68. What is the ratio of the Health expenditure (as % of GDP) in Turkey in 2008 to that in 2009?
Offer a very short reply. 0.9. What is the difference between the highest and the second highest Health expenditure (as % of GDP) in Fragile and conflict affected situations?
Provide a short and direct response. 0.15. What is the difference between the highest and the second highest Health expenditure (as % of GDP) in Gabon?
Make the answer very short. 0.01. What is the difference between the highest and the second highest Health expenditure (as % of GDP) of Turkey?
Your response must be concise. 0.49. What is the difference between the highest and the lowest Health expenditure (as % of GDP) of Fragile and conflict affected situations?
Give a very brief answer. 0.72. What is the difference between the highest and the lowest Health expenditure (as % of GDP) of Gabon?
Your answer should be compact. 0.51. What is the difference between the highest and the lowest Health expenditure (as % of GDP) of Turkey?
Ensure brevity in your answer.  1.23. 